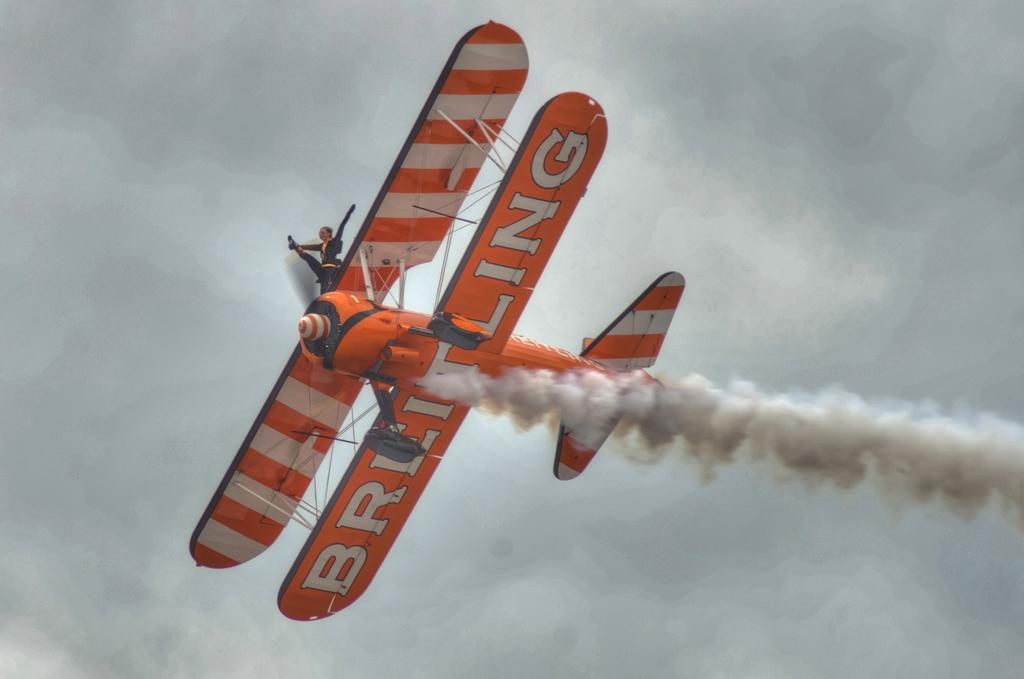What word does the plane have on its second wing?
Your response must be concise. Breitling. 